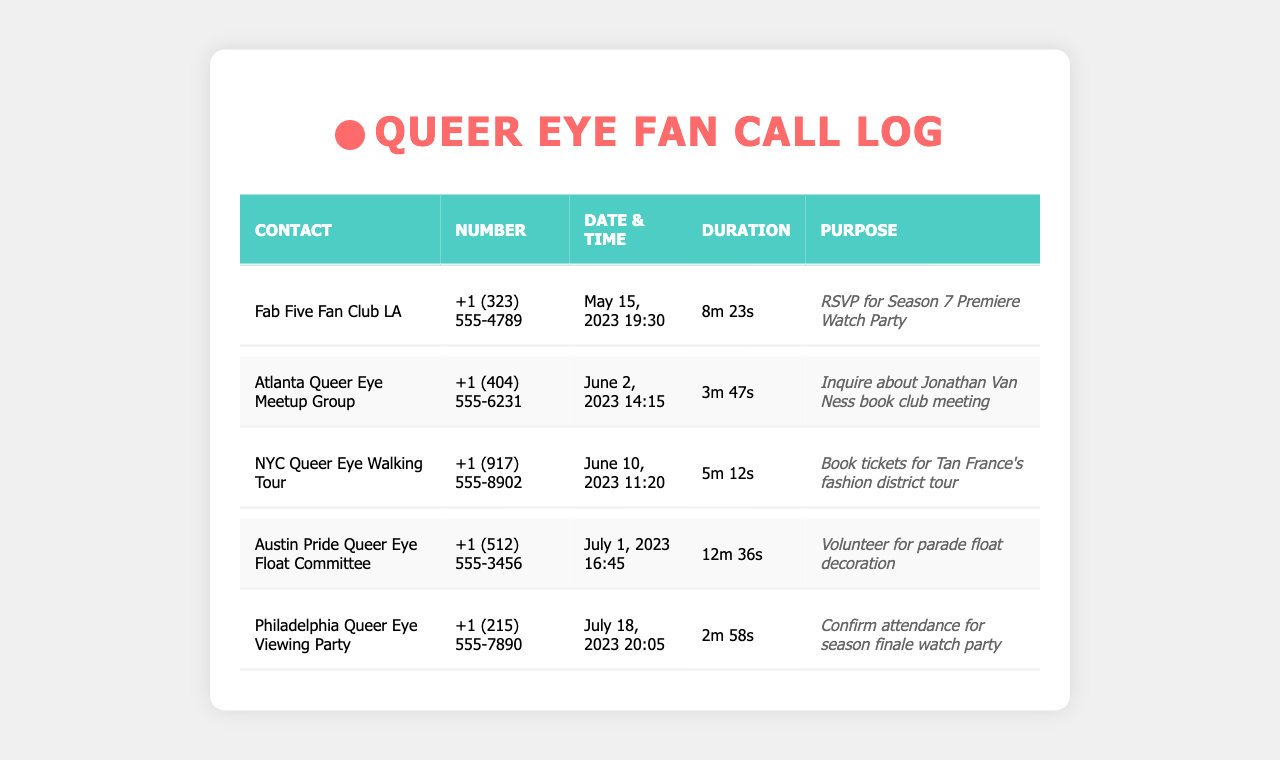what is the longest call duration? The longest call duration is identified from the list of durations, which is 12m 36s for the Austin Pride Queer Eye Float Committee call.
Answer: 12m 36s who did I call to RSVP for the Season 7 Premiere Watch Party? The contact I called for the RSVP is Fab Five Fan Club LA, as indicated in the document.
Answer: Fab Five Fan Club LA what was the purpose of the call to the Philadelphia Queer Eye Viewing Party? The purpose of that call was to confirm attendance for the season finale watch party, which is stated in the document.
Answer: Confirm attendance for season finale watch party how many minutes was the call to the Atlanta Queer Eye Meetup Group? The call duration to the Atlanta Queer Eye Meetup Group was measured at 3 minutes and 47 seconds; this is derived directly from the document.
Answer: 3m 47s which date did I call to book tickets for Tan France's tour? The date of the call for booking tickets was June 10, 2023, as mentioned in the records.
Answer: June 10, 2023 what is the phone number for the Austin Pride Queer Eye Float Committee? The phone number is found in the document as +1 (512) 555-3456, associated with the call to this committee.
Answer: +1 (512) 555-3456 what type of group is the NYC Queer Eye Walking Tour? This group is categorized as an event type, specifically a tour, based on the purpose described in the document.
Answer: Walking Tour what was inquired about during the call to the Atlanta Queer Eye Meetup Group? The inquiry was related to Jonathan Van Ness book club meeting, as detailed in the call purpose.
Answer: Jonathan Van Ness book club meeting 